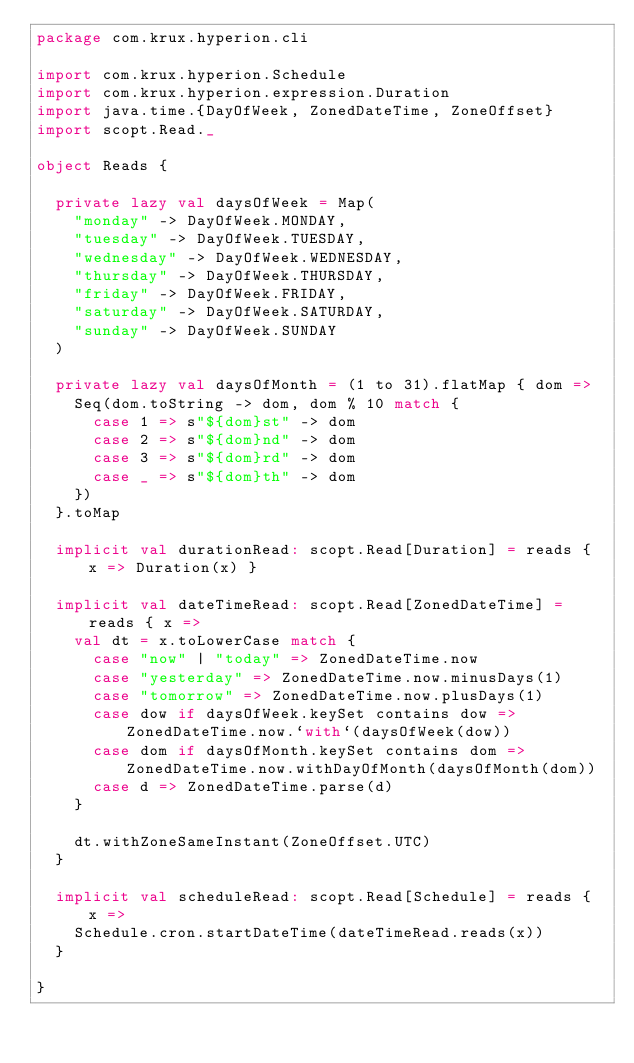<code> <loc_0><loc_0><loc_500><loc_500><_Scala_>package com.krux.hyperion.cli

import com.krux.hyperion.Schedule
import com.krux.hyperion.expression.Duration
import java.time.{DayOfWeek, ZonedDateTime, ZoneOffset}
import scopt.Read._

object Reads {

  private lazy val daysOfWeek = Map(
    "monday" -> DayOfWeek.MONDAY,
    "tuesday" -> DayOfWeek.TUESDAY,
    "wednesday" -> DayOfWeek.WEDNESDAY,
    "thursday" -> DayOfWeek.THURSDAY,
    "friday" -> DayOfWeek.FRIDAY,
    "saturday" -> DayOfWeek.SATURDAY,
    "sunday" -> DayOfWeek.SUNDAY
  )

  private lazy val daysOfMonth = (1 to 31).flatMap { dom =>
    Seq(dom.toString -> dom, dom % 10 match {
      case 1 => s"${dom}st" -> dom
      case 2 => s"${dom}nd" -> dom
      case 3 => s"${dom}rd" -> dom
      case _ => s"${dom}th" -> dom
    })
  }.toMap

  implicit val durationRead: scopt.Read[Duration] = reads { x => Duration(x) }

  implicit val dateTimeRead: scopt.Read[ZonedDateTime] = reads { x =>
    val dt = x.toLowerCase match {
      case "now" | "today" => ZonedDateTime.now
      case "yesterday" => ZonedDateTime.now.minusDays(1)
      case "tomorrow" => ZonedDateTime.now.plusDays(1)
      case dow if daysOfWeek.keySet contains dow => ZonedDateTime.now.`with`(daysOfWeek(dow))
      case dom if daysOfMonth.keySet contains dom => ZonedDateTime.now.withDayOfMonth(daysOfMonth(dom))
      case d => ZonedDateTime.parse(d)
    }

    dt.withZoneSameInstant(ZoneOffset.UTC)
  }

  implicit val scheduleRead: scopt.Read[Schedule] = reads { x =>
    Schedule.cron.startDateTime(dateTimeRead.reads(x))
  }

}
</code> 